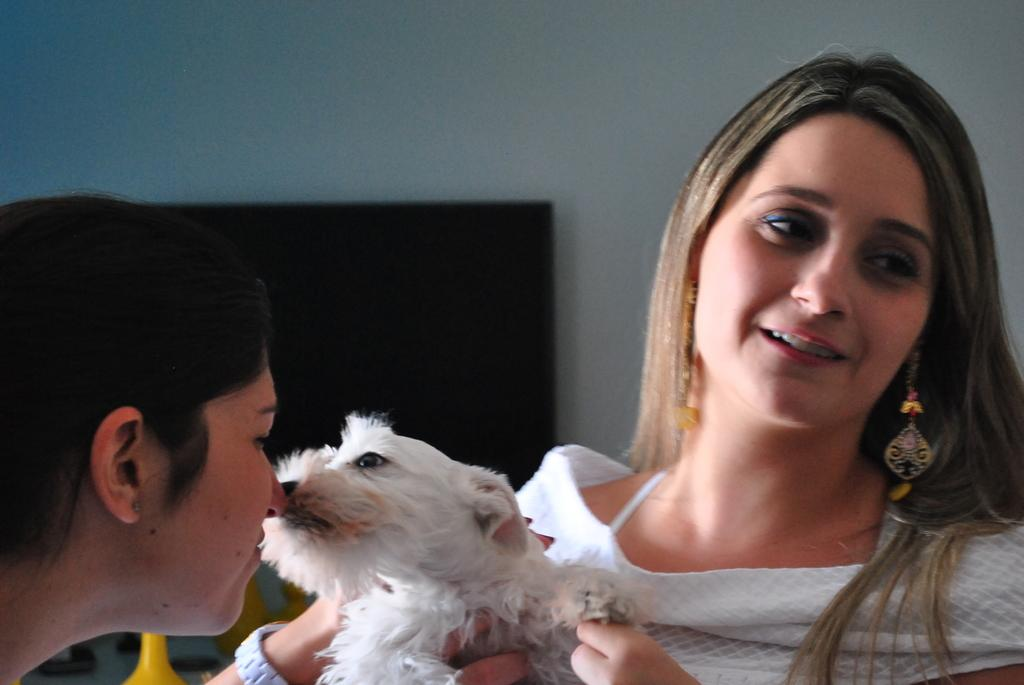How many people are in the image? There are two women in the image. What other living creature is present in the image? There is a dog in the image. Can you describe the clothing of one of the women? One of the women is wearing a white top. What type of bed is visible in the image? There is no bed present in the image. What kind of voyage are the women and the dog embarking on in the image? There is no indication of a voyage in the image; it simply shows two women and a dog together. 